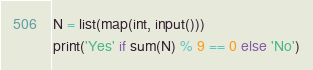<code> <loc_0><loc_0><loc_500><loc_500><_Python_>N = list(map(int, input()))
print('Yes' if sum(N) % 9 == 0 else 'No')
</code> 